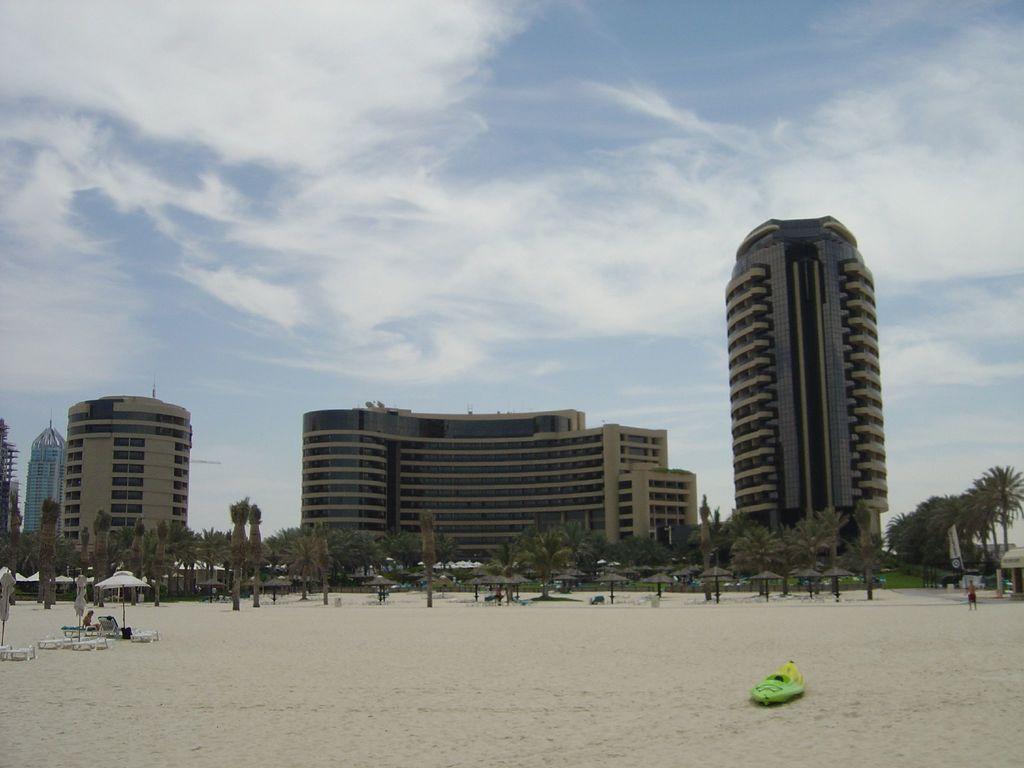In one or two sentences, can you explain what this image depicts? In this image, I can see the buildings, trees and thatched umbrellas. At the bottom of the image, there are chairs, a patio umbrella and a boat on the sand. On the right side of the image, I can see a person standing and there is an advertising flag. In the background, there is the sky. 